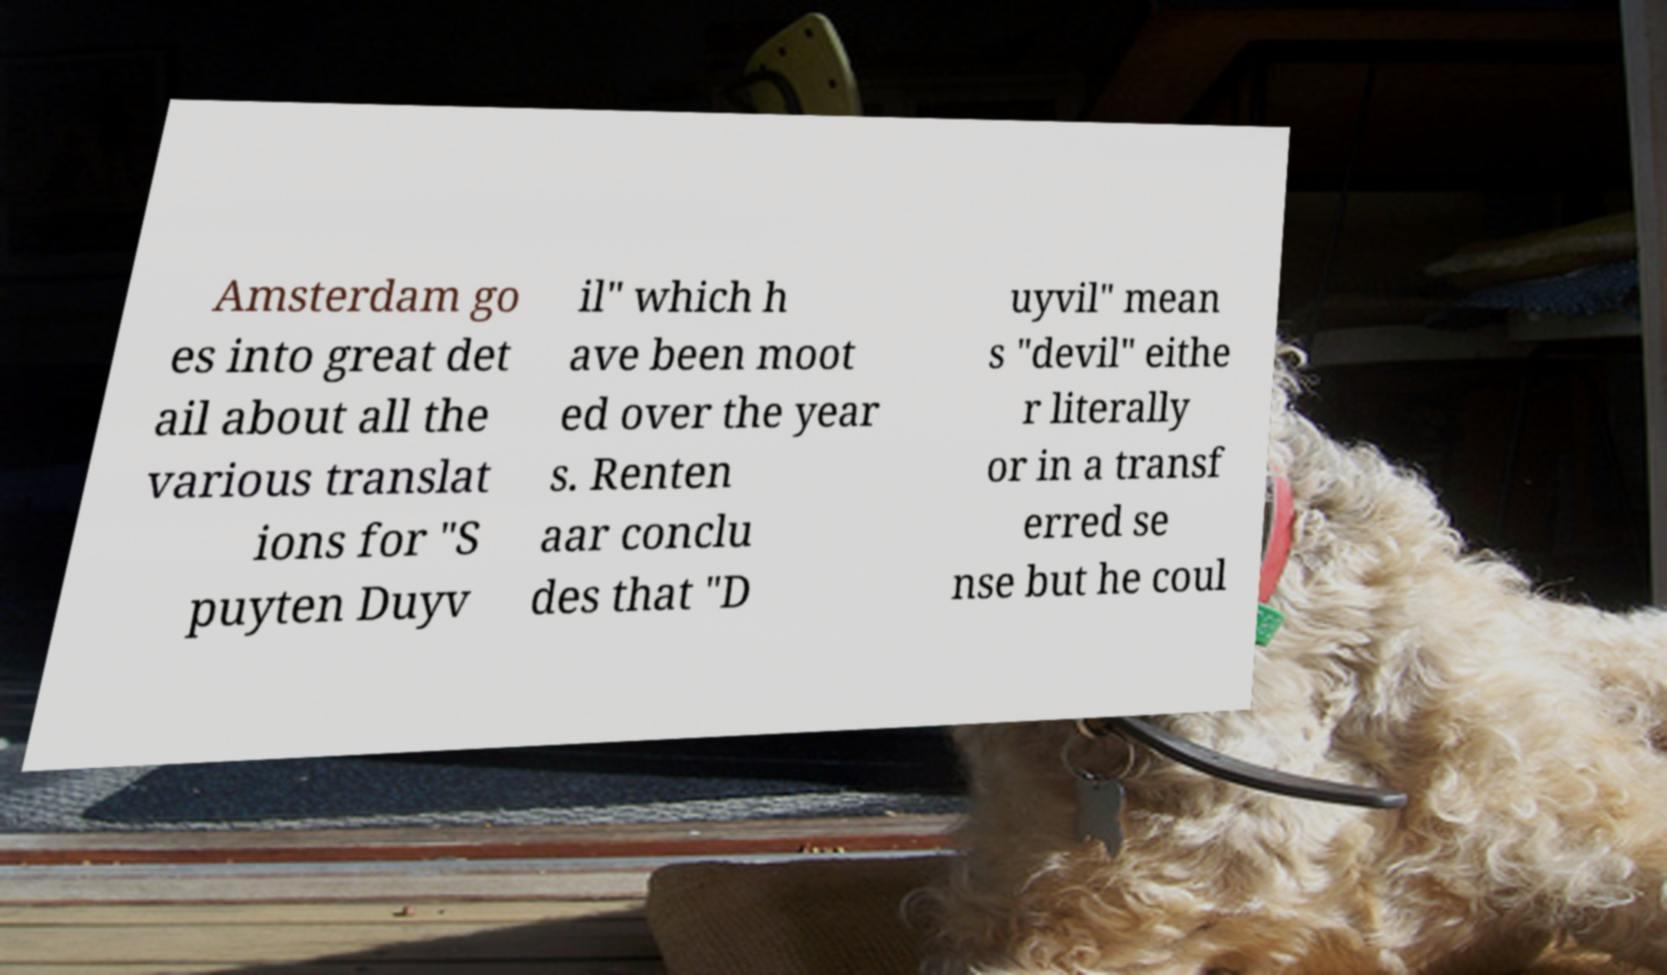Please identify and transcribe the text found in this image. Amsterdam go es into great det ail about all the various translat ions for "S puyten Duyv il" which h ave been moot ed over the year s. Renten aar conclu des that "D uyvil" mean s "devil" eithe r literally or in a transf erred se nse but he coul 